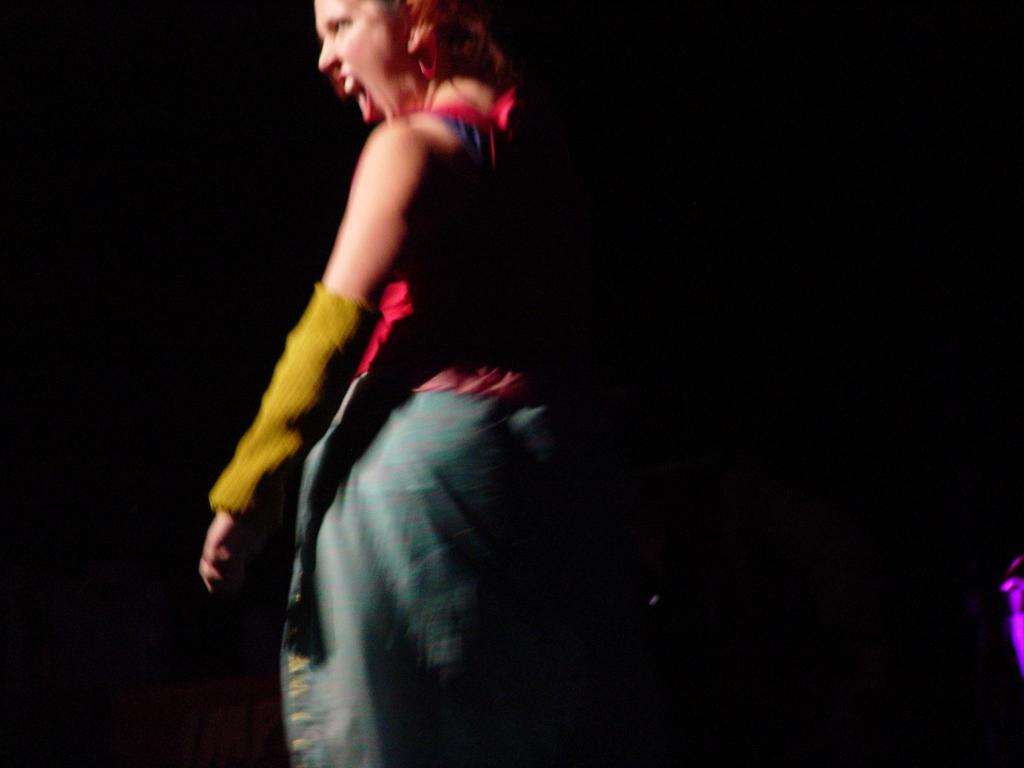What is the main subject of the image? There is a person standing in the image. What is the person doing in the image? The person appears to be shouting. What can be observed about the background of the image? The background of the image is dark. What type of committee can be seen in the image? There is no committee present in the image; it features a person standing and shouting. How many people are driving in the image? There is no driving activity depicted in the image. 